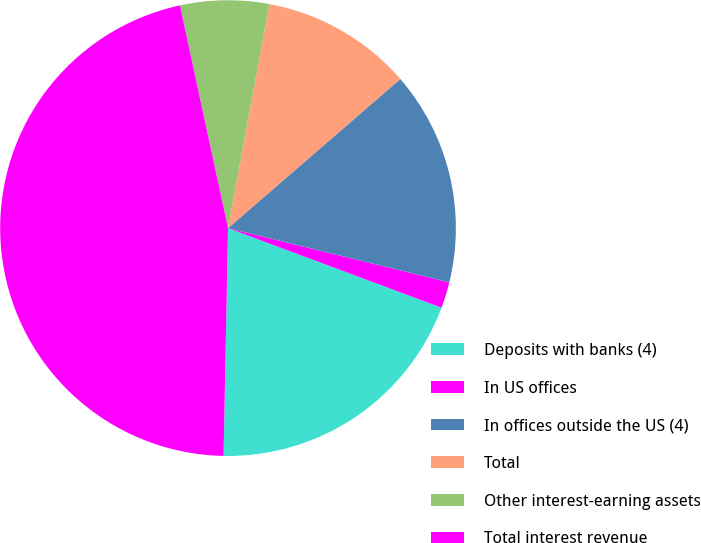<chart> <loc_0><loc_0><loc_500><loc_500><pie_chart><fcel>Deposits with banks (4)<fcel>In US offices<fcel>In offices outside the US (4)<fcel>Total<fcel>Other interest-earning assets<fcel>Total interest revenue<nl><fcel>19.63%<fcel>1.85%<fcel>15.18%<fcel>10.74%<fcel>6.29%<fcel>46.3%<nl></chart> 